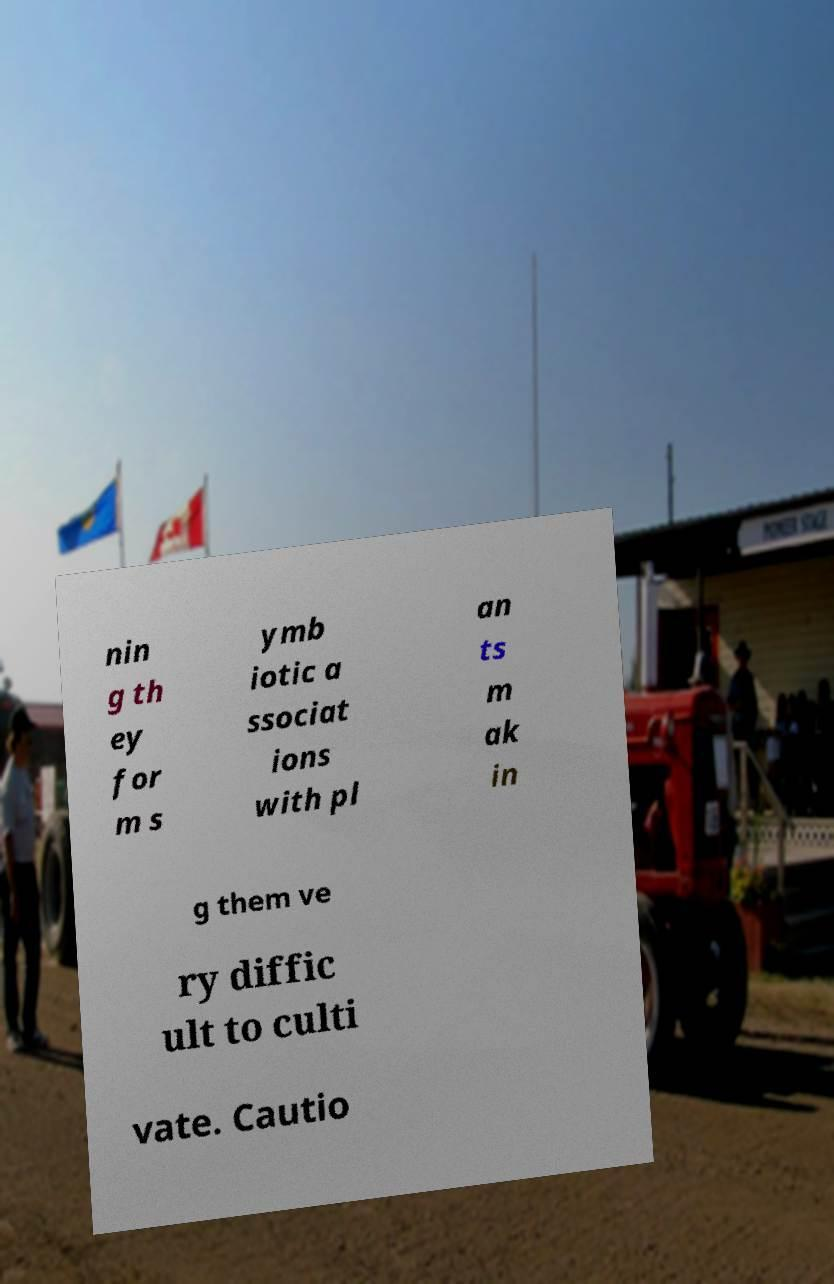Can you accurately transcribe the text from the provided image for me? nin g th ey for m s ymb iotic a ssociat ions with pl an ts m ak in g them ve ry diffic ult to culti vate. Cautio 